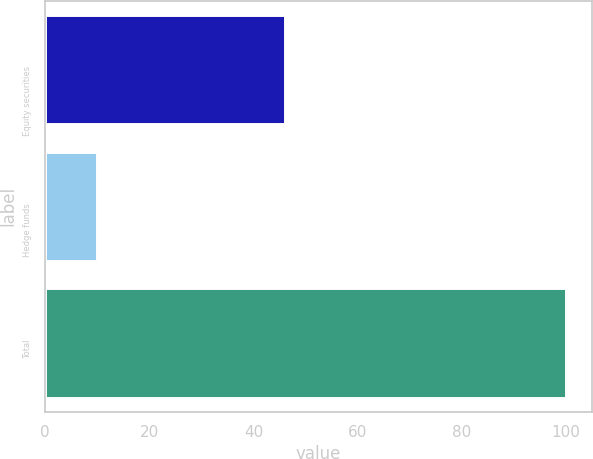Convert chart. <chart><loc_0><loc_0><loc_500><loc_500><bar_chart><fcel>Equity securities<fcel>Hedge funds<fcel>Total<nl><fcel>46<fcel>10<fcel>100<nl></chart> 